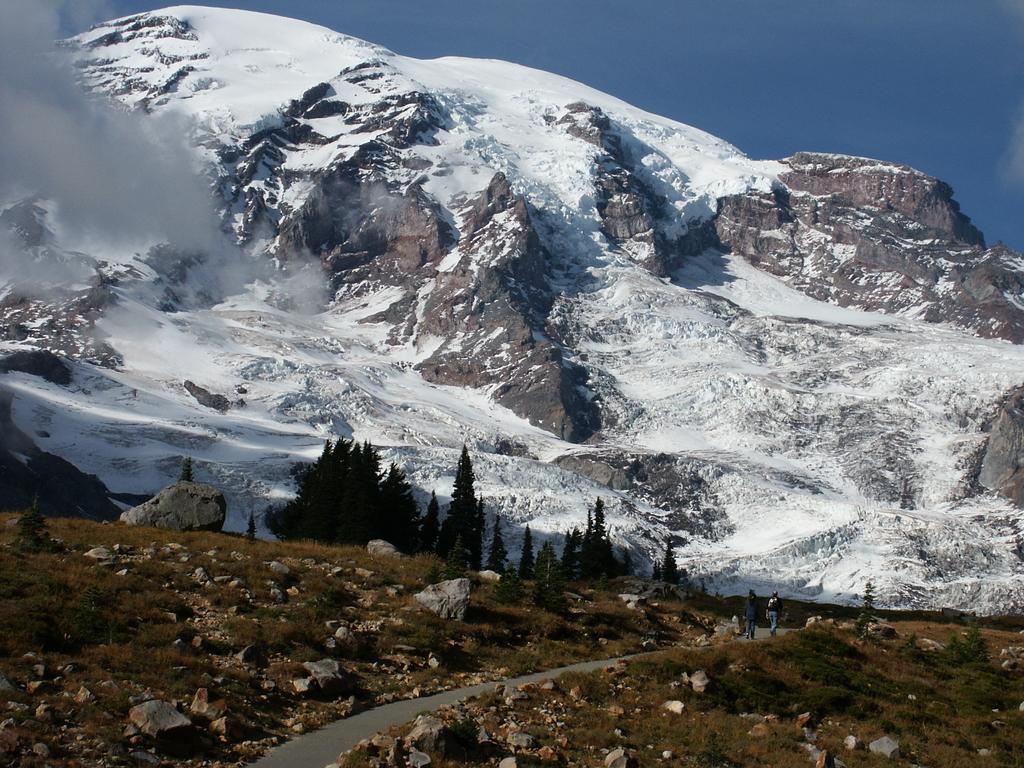Describe this image in one or two sentences. In this image at the bottom there are some plants, rocks, and there is a walkway and there are some people walking. And in the background there are trees, rocks and snow mountains and there is some fog coming out. At the top there is sky. 